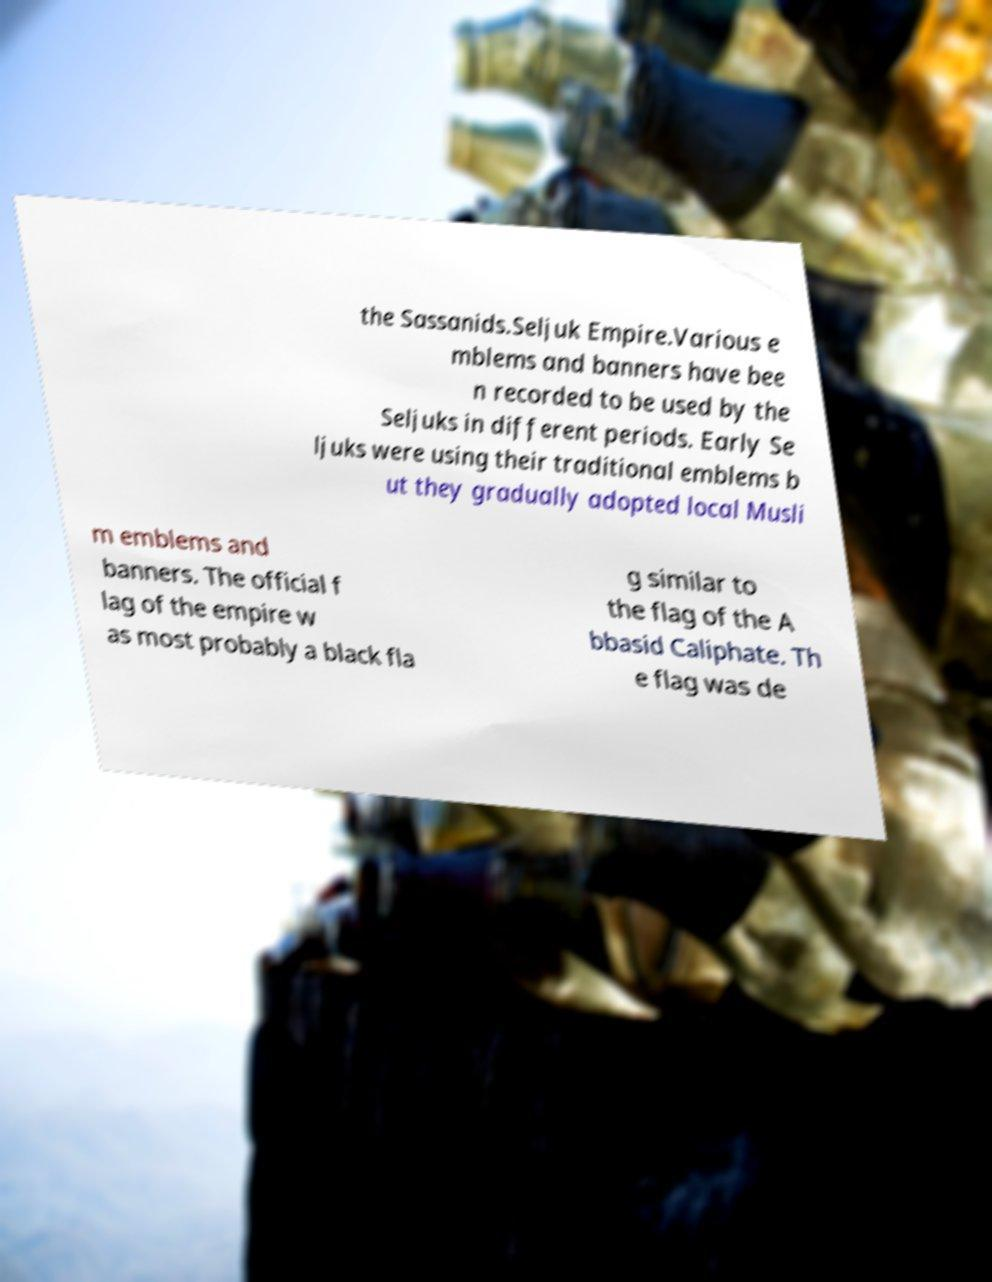There's text embedded in this image that I need extracted. Can you transcribe it verbatim? the Sassanids.Seljuk Empire.Various e mblems and banners have bee n recorded to be used by the Seljuks in different periods. Early Se ljuks were using their traditional emblems b ut they gradually adopted local Musli m emblems and banners. The official f lag of the empire w as most probably a black fla g similar to the flag of the A bbasid Caliphate. Th e flag was de 